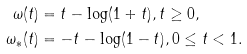Convert formula to latex. <formula><loc_0><loc_0><loc_500><loc_500>\omega ( t ) & = t - \log ( 1 + t ) , t \geq 0 , \\ \omega _ { * } ( t ) & = - t - \log ( 1 - t ) , 0 \leq t < 1 .</formula> 